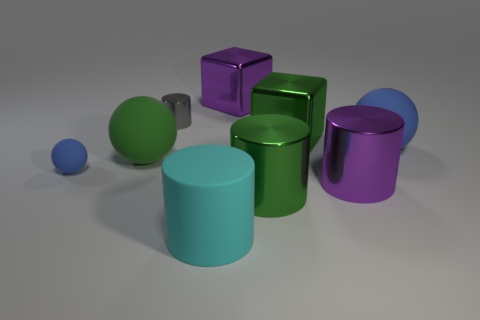There is a block that is behind the small shiny thing; what color is it? The block situated behind the small shiny sphere appears to be purple with a reflective surface, giving it a vibrant and glossy look. 